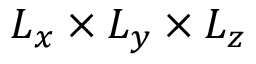Convert formula to latex. <formula><loc_0><loc_0><loc_500><loc_500>L _ { x } \times L _ { y } \times L _ { z }</formula> 